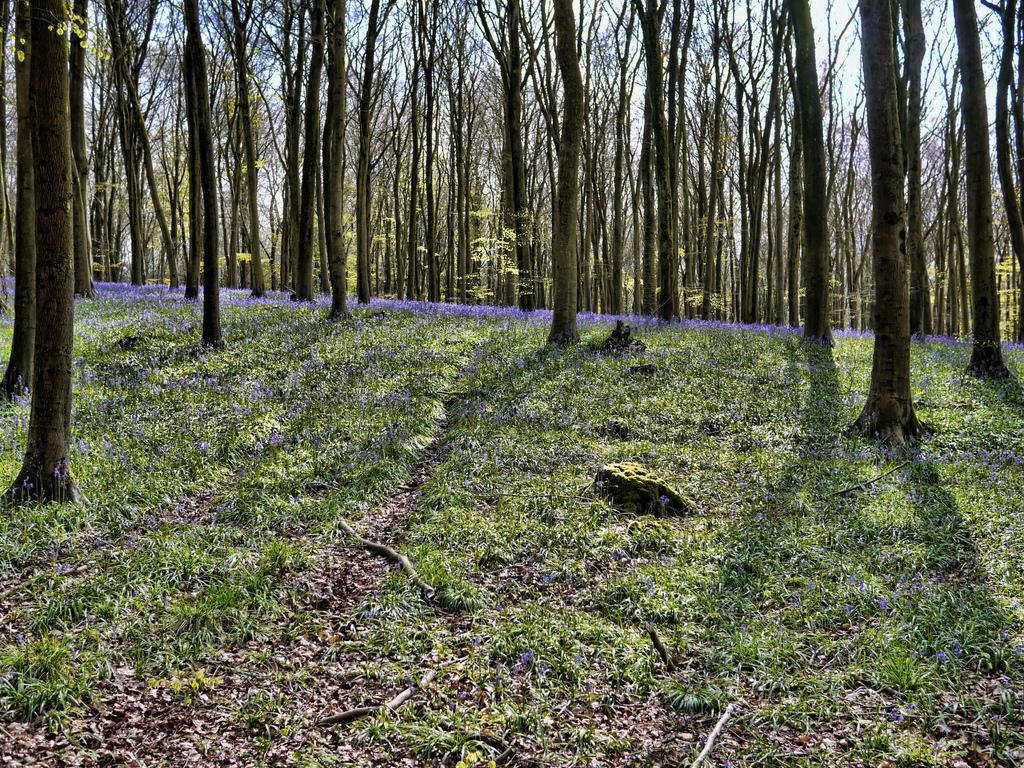What type of terrain is visible at the bottom of the image? There is a grassy land at the bottom of the image. What can be seen in the background of the image? There are trees in the background of the image. Is there a tiger swinging from a tree in the image? No, there is no tiger or swing present in the image. 